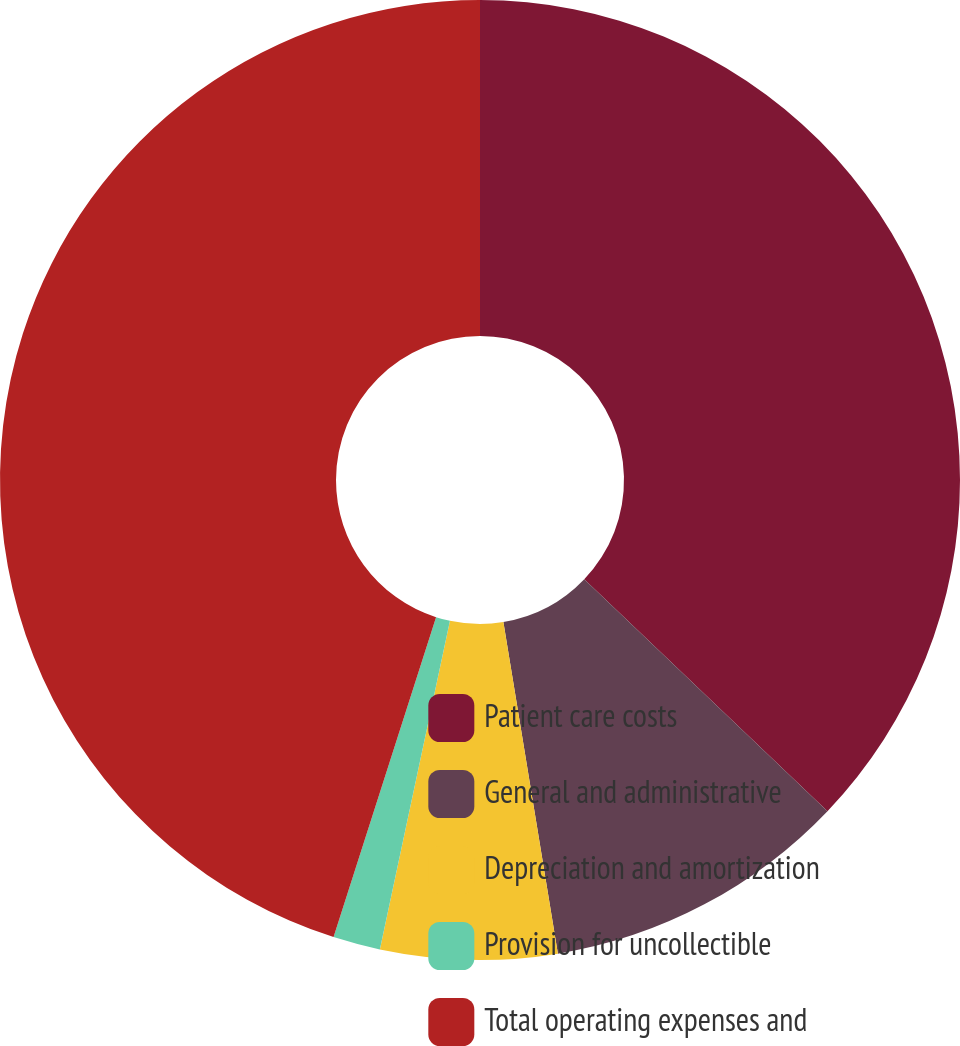Convert chart to OTSL. <chart><loc_0><loc_0><loc_500><loc_500><pie_chart><fcel>Patient care costs<fcel>General and administrative<fcel>Depreciation and amortization<fcel>Provision for uncollectible<fcel>Total operating expenses and<nl><fcel>37.12%<fcel>10.29%<fcel>5.94%<fcel>1.59%<fcel>45.07%<nl></chart> 